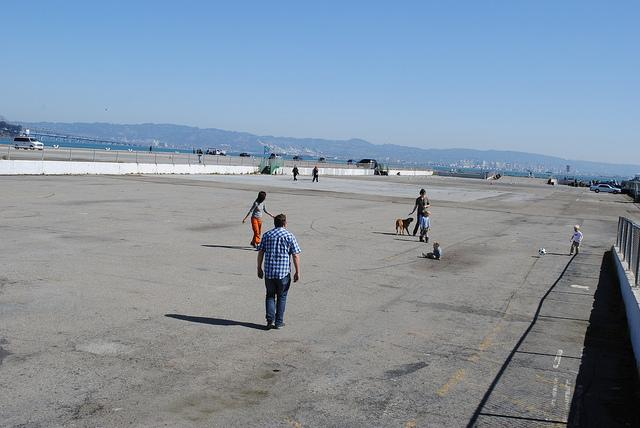What venue is it likely to be? Please explain your reasoning. airfield. It looks like they are on a tarmac. 